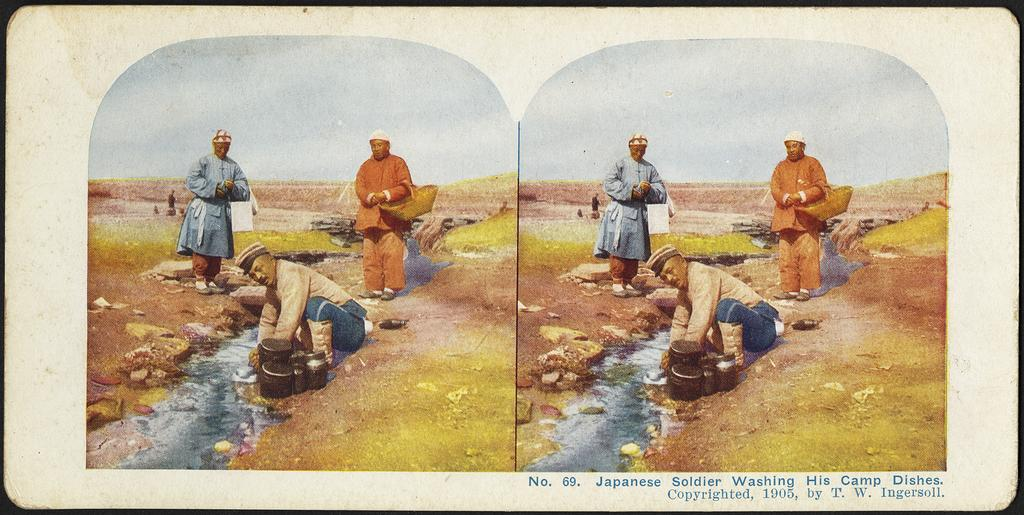What is present on the paper in the image? There are two pictures on the paper. How many people are depicted in the pictures? There are three persons in the pictures. What type of natural environment is shown in the pictures? There is grass and water in the pictures. What objects can be seen in the pictures? There are bowls in the pictures. Is there any text on the paper? Yes, there is text at the bottom of the paper. What type of cub can be seen playing with a bean in the pictures? There is no cub or bean present in the pictures; they depict three persons in a grassy and watery environment with bowls. Can you tell me how many bats are flying in the pictures? There are no bats present in the pictures; they showcase a grassy and watery environment with three persons and bowls. 